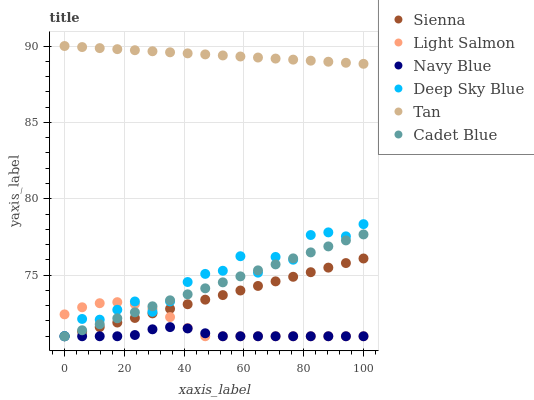Does Navy Blue have the minimum area under the curve?
Answer yes or no. Yes. Does Tan have the maximum area under the curve?
Answer yes or no. Yes. Does Cadet Blue have the minimum area under the curve?
Answer yes or no. No. Does Cadet Blue have the maximum area under the curve?
Answer yes or no. No. Is Sienna the smoothest?
Answer yes or no. Yes. Is Deep Sky Blue the roughest?
Answer yes or no. Yes. Is Cadet Blue the smoothest?
Answer yes or no. No. Is Cadet Blue the roughest?
Answer yes or no. No. Does Light Salmon have the lowest value?
Answer yes or no. Yes. Does Tan have the lowest value?
Answer yes or no. No. Does Tan have the highest value?
Answer yes or no. Yes. Does Cadet Blue have the highest value?
Answer yes or no. No. Is Cadet Blue less than Tan?
Answer yes or no. Yes. Is Tan greater than Deep Sky Blue?
Answer yes or no. Yes. Does Cadet Blue intersect Light Salmon?
Answer yes or no. Yes. Is Cadet Blue less than Light Salmon?
Answer yes or no. No. Is Cadet Blue greater than Light Salmon?
Answer yes or no. No. Does Cadet Blue intersect Tan?
Answer yes or no. No. 